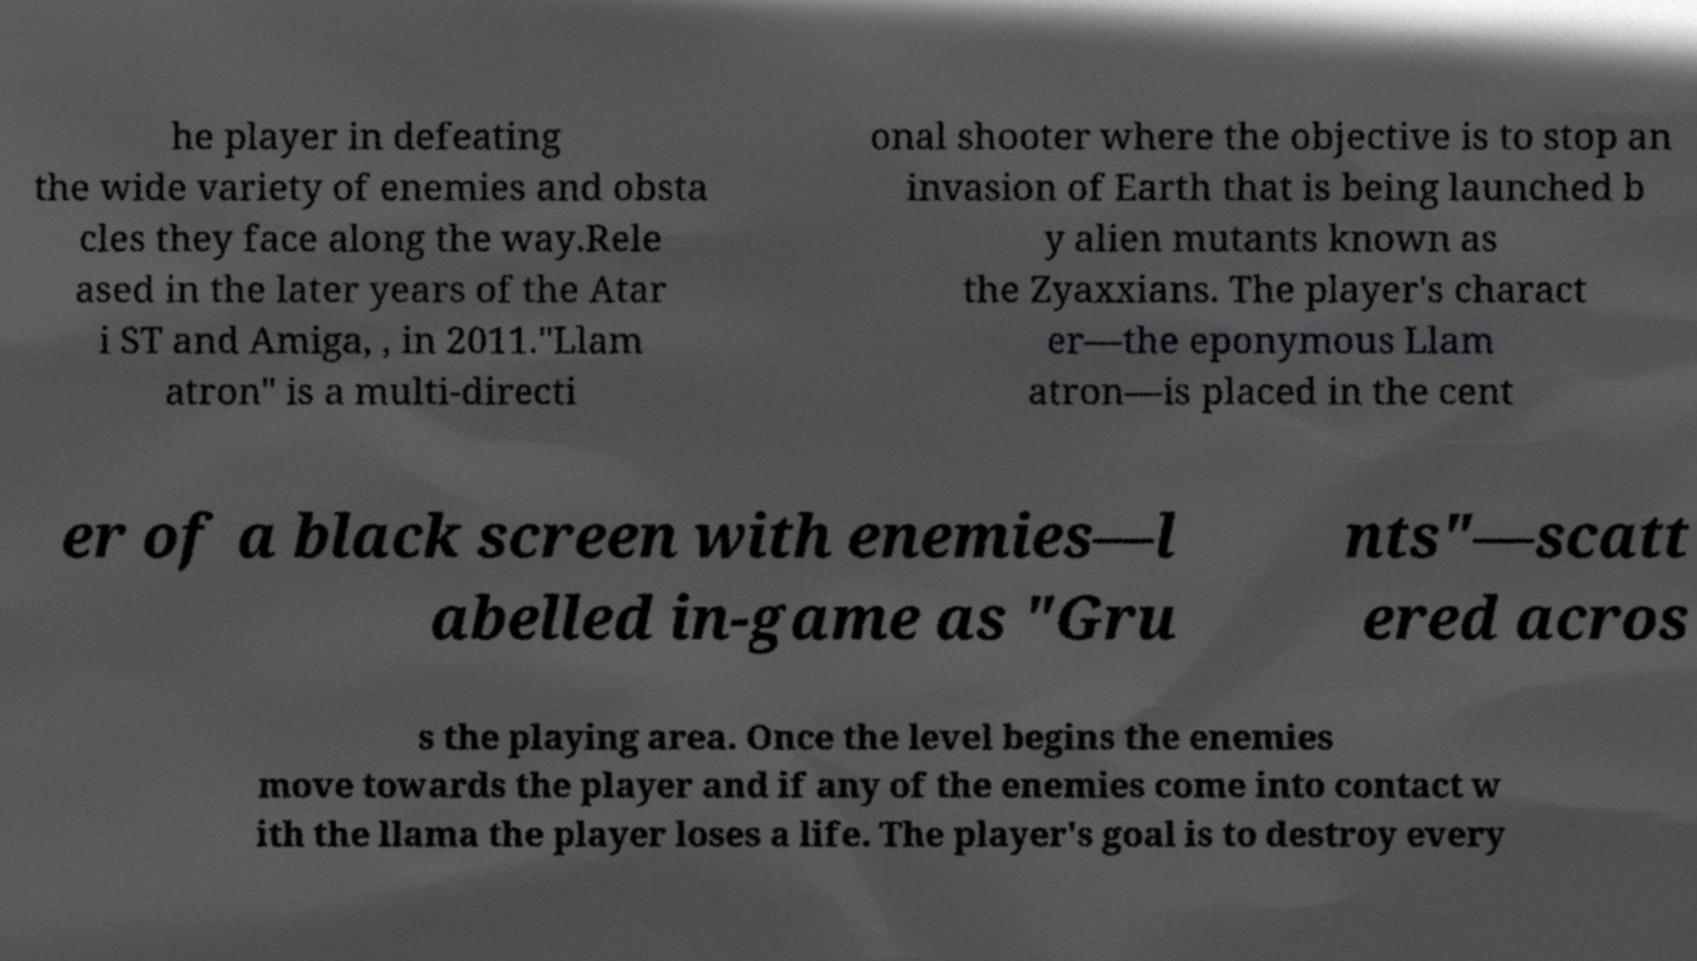Please identify and transcribe the text found in this image. he player in defeating the wide variety of enemies and obsta cles they face along the way.Rele ased in the later years of the Atar i ST and Amiga, , in 2011."Llam atron" is a multi-directi onal shooter where the objective is to stop an invasion of Earth that is being launched b y alien mutants known as the Zyaxxians. The player's charact er—the eponymous Llam atron—is placed in the cent er of a black screen with enemies—l abelled in-game as "Gru nts"—scatt ered acros s the playing area. Once the level begins the enemies move towards the player and if any of the enemies come into contact w ith the llama the player loses a life. The player's goal is to destroy every 